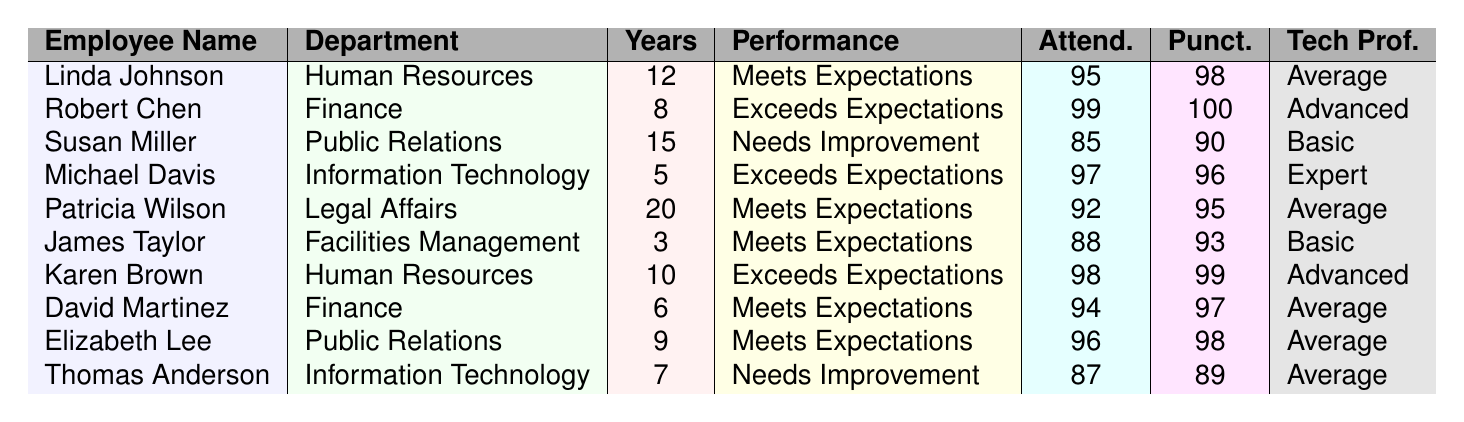What is the maximum attendance score among the employees? From the data, we can see the attendance scores: 95, 99, 85, 97, 92, 88, 98, 94, 96, and 87. The highest value is 99.
Answer: 99 How many employees have a performance rating of 'Exceeds Expectations'? By reviewing the performance ratings, the employees with 'Exceeds Expectations' are Robert Chen, Michael Davis, and Karen Brown. This totals to three employees.
Answer: 3 What is the average punctuality score of all employees? The punctuality scores are: 98, 100, 90, 96, 95, 93, 99, 97, 98, and 89. Summing these scores gives us 98 + 100 + 90 + 96 + 95 + 93 + 99 + 97 + 98 + 89 =  945. Dividing by 10 (the number of employees), yields an average of 94.5.
Answer: 94.5 Is there any employee with a performance rating of 'Needs Improvement'? Checking through the performance ratings listed, we find Susan Miller and Thomas Anderson both have a rating of 'Needs Improvement.' Thus, the answer is yes.
Answer: Yes What is the difference in the 'Years of Service' between the longest-serving employee and the shortest-serving employee? The longest-serving employee is Patricia Wilson with 20 years, and the shortest-serving employee is James Taylor with 3 years. The difference in years of service is 20 - 3 = 17 years.
Answer: 17 Which department has the highest number of employees rated as 'Meets Expectations'? Looking at the performance ratings, we observe that Human Resources (Linda Johnson and Karen Brown) and Finance (David Martinez) have 2 employees rated as 'Meets Expectations,' while other departments have one each. So Human Resources is the department with the most employees rated 'Meets Expectations.'
Answer: Human Resources What is the total number of employees who work in the Information Technology department? Upon examining the data, there are two employees in the Information Technology department: Michael Davis and Thomas Anderson. Therefore, the total is 2.
Answer: 2 Are there any employees with an 'Average' technology proficiency rating? Yes, Linda Johnson, Patricia Wilson, James Taylor, and Thomas Anderson all have an 'Average' rating in technology proficiency. Thus, the answer is yes.
Answer: Yes What is the combined attendance score of all employees rated as 'Exceeds Expectations'? The attendance scores for those rated as 'Exceeds Expectations' (Robert Chen, Michael Davis, and Karen Brown) are 99, 97, and 98. Adding those gives 99 + 97 + 98 = 294.
Answer: 294 Which employee has the highest technology proficiency? Michael Davis is noted to have 'Expert' technology proficiency, which is the highest among all entries noted.
Answer: Michael Davis How many employees have worked for more than 10 years? Upon reviewing the 'Years of Service', the employees over 10 years are Susan Miller (15 years) and Patricia Wilson (20 years). This makes a total of 2 employees.
Answer: 2 